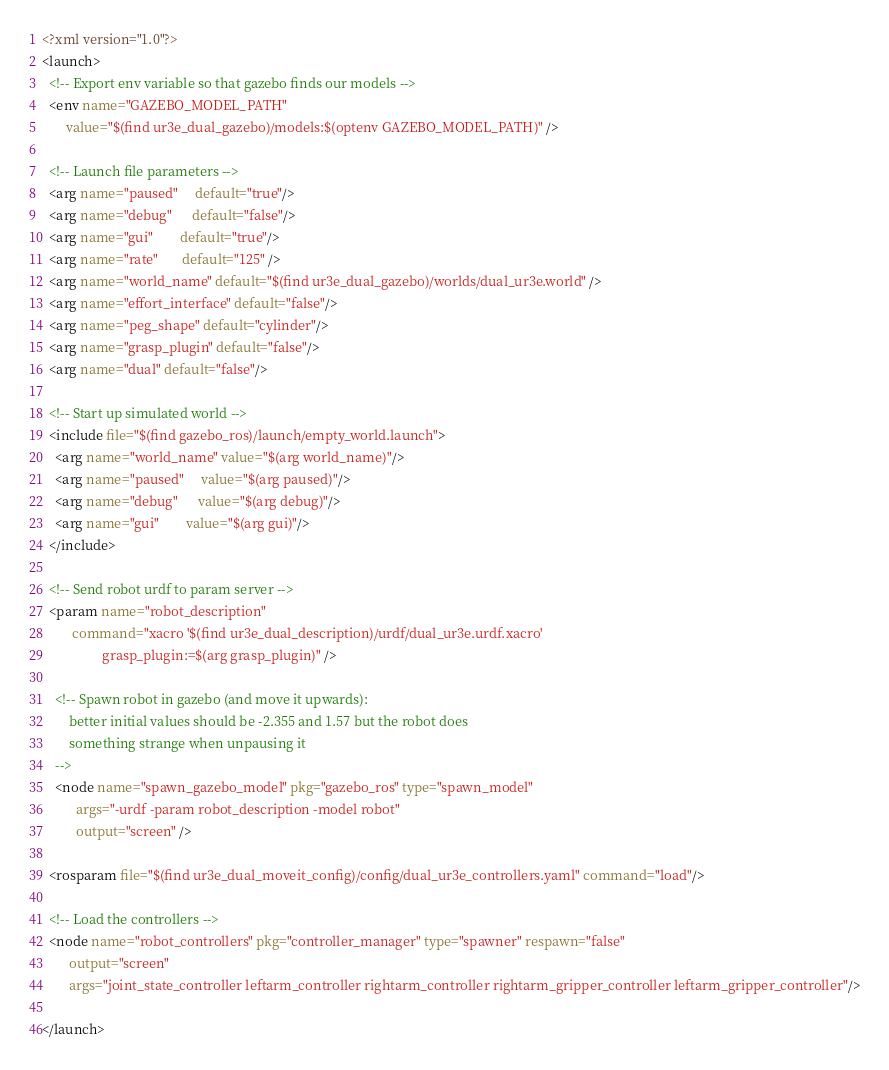Convert code to text. <code><loc_0><loc_0><loc_500><loc_500><_XML_><?xml version="1.0"?>
<launch>
  <!-- Export env variable so that gazebo finds our models -->
  <env name="GAZEBO_MODEL_PATH"
       value="$(find ur3e_dual_gazebo)/models:$(optenv GAZEBO_MODEL_PATH)" />
  
  <!-- Launch file parameters -->
  <arg name="paused"     default="true"/>
  <arg name="debug"      default="false"/>
  <arg name="gui"        default="true"/>
  <arg name="rate"       default="125" />
  <arg name="world_name" default="$(find ur3e_dual_gazebo)/worlds/dual_ur3e.world" />
  <arg name="effort_interface" default="false"/>
  <arg name="peg_shape" default="cylinder"/>
  <arg name="grasp_plugin" default="false"/>
  <arg name="dual" default="false"/>

  <!-- Start up simulated world -->
  <include file="$(find gazebo_ros)/launch/empty_world.launch">
    <arg name="world_name" value="$(arg world_name)"/>
    <arg name="paused"     value="$(arg paused)"/>
    <arg name="debug"      value="$(arg debug)"/>
    <arg name="gui"        value="$(arg gui)"/>
  </include>

  <!-- Send robot urdf to param server -->
  <param name="robot_description" 
         command="xacro '$(find ur3e_dual_description)/urdf/dual_ur3e.urdf.xacro'
                  grasp_plugin:=$(arg grasp_plugin)" />

    <!-- Spawn robot in gazebo (and move it upwards):
        better initial values should be -2.355 and 1.57 but the robot does
        something strange when unpausing it
    -->
    <node name="spawn_gazebo_model" pkg="gazebo_ros" type="spawn_model"
          args="-urdf -param robot_description -model robot"
          output="screen" />

  <rosparam file="$(find ur3e_dual_moveit_config)/config/dual_ur3e_controllers.yaml" command="load"/>

  <!-- Load the controllers -->
  <node name="robot_controllers" pkg="controller_manager" type="spawner" respawn="false"
        output="screen"
        args="joint_state_controller leftarm_controller rightarm_controller rightarm_gripper_controller leftarm_gripper_controller"/>

</launch>
</code> 